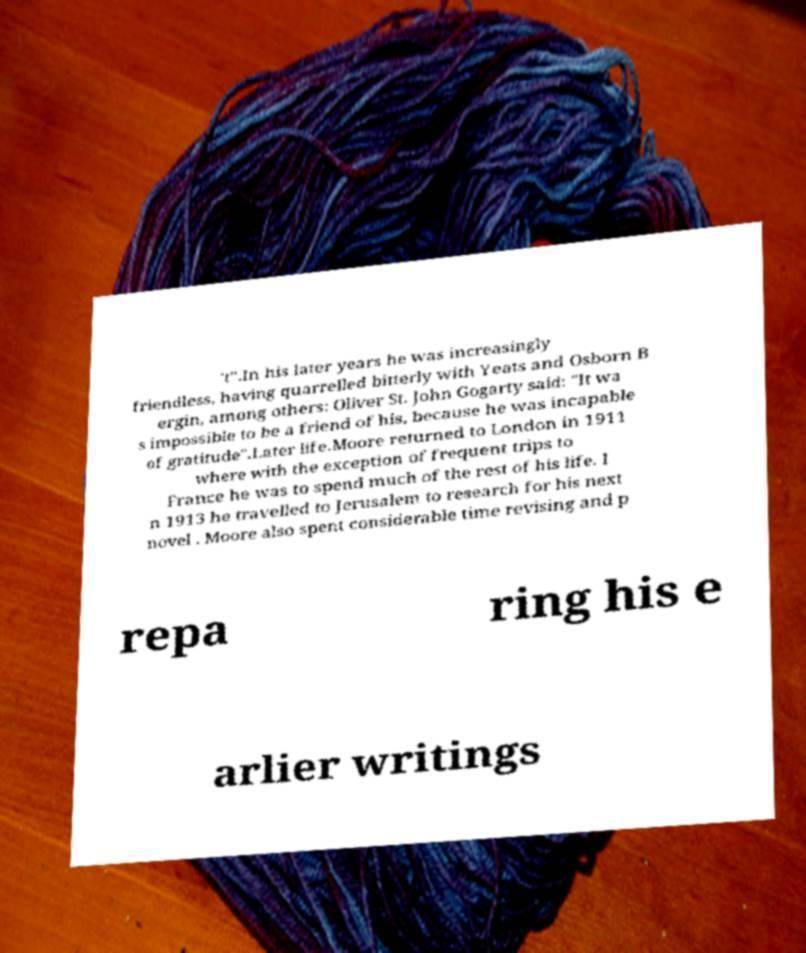Can you read and provide the text displayed in the image?This photo seems to have some interesting text. Can you extract and type it out for me? 't".In his later years he was increasingly friendless, having quarrelled bitterly with Yeats and Osborn B ergin, among others: Oliver St. John Gogarty said: "It wa s impossible to be a friend of his, because he was incapable of gratitude".Later life.Moore returned to London in 1911 where with the exception of frequent trips to France he was to spend much of the rest of his life. I n 1913 he travelled to Jerusalem to research for his next novel . Moore also spent considerable time revising and p repa ring his e arlier writings 